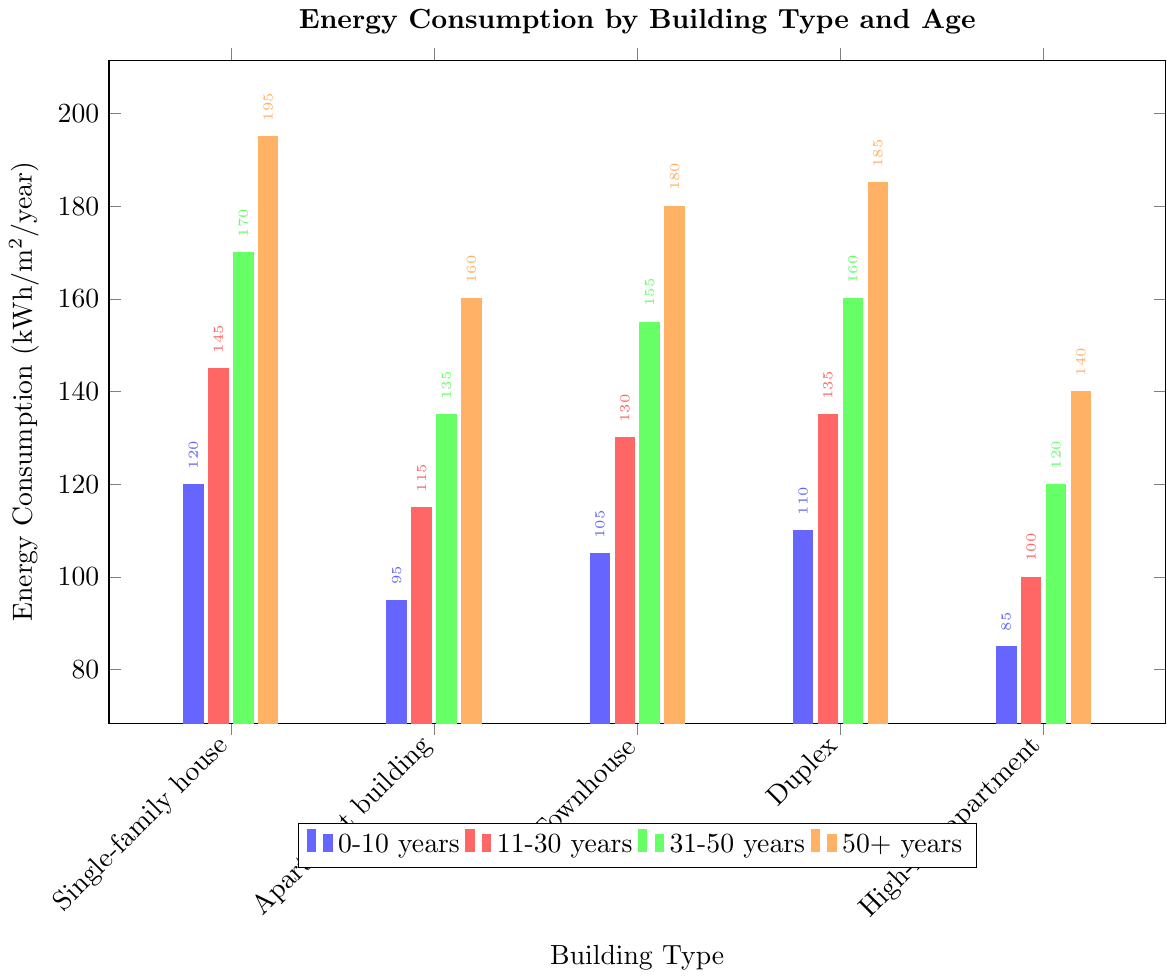How does energy consumption vary between the different building types for buildings that are 0-10 years old? To answer this question, compare the heights of the blue bars for each building type. Single-family house has 120 kWh/m²/year, Apartment building has 95 kWh/m²/year, Townhouse has 105 kWh/m²/year, Duplex has 110 kWh/m²/year, and High-rise apartment has 85 kWh/m²/year.
Answer: High-rise apartment consumes the least, followed by Apartment building, Townhouse, Duplex, and Single-family house consumes the most Which building type has the highest energy consumption for buildings aged 50+ years? For buildings aged 50+ years, look for the highest orange bar. Single-family house has 195 kWh/m²/year, Apartment building has 160 kWh/m²/year, Townhouse has 180 kWh/m²/year, Duplex has 185 kWh/m²/year, and High-rise apartment has 140 kWh/m²/year.
Answer: Single-family house How does the energy consumption of Duplexes change with building age? To answer this question, examine the heights of the bars for Duplexes across all age groups: 0-10 years is 110 kWh/m²/year, 11-30 years is 135 kWh/m²/year, 31-50 years is 160 kWh/m²/year, and 50+ years is 185 kWh/m²/year.
Answer: Increases with age Which age group shows the highest overall energy consumption? To determine this, look for the highest bar within each age group. The orange bars (50+ years) generally show the highest energy consumption across all building types.
Answer: 50+ years Is energy consumption more affected by building type or building age? Compare variations in bar height within each age group (across different building types) and within each building type (across different age groups). Significant increases in consumption with age are more evident than variations between building types of the same age group.
Answer: Building age What is the average energy consumption for Apartment buildings across all age groups? Sum the energy consumption values for Apartment buildings and divide by the number of age groups: (95 + 115 + 135 + 160) / 4.
Answer: 126.25 kWh/m²/year Compare the energy consumption of Single-family houses aged 0-10 years and High-rise apartments aged 50+ years. Look at the blue bar for Single-family houses and the orange bar for High-rise apartments. Single-family houses consume 120 kWh/m²/year, and High-rise apartments consume 140 kWh/m²/year.
Answer: High-rise apartments consume more For which building type does energy consumption increase the least with building age? Compare the differences in bar heights from 0-10 years to 50+ years for each building type. High-rise apartments go from 85 to 140, a difference of 55, which is the smallest increase compared to others.
Answer: High-rise apartment Which building type shows the most considerable increase in energy consumption from 0-10 years to 50+ years? Check the increments for each building type. Single-family house increases from 120 to 195, a difference of 75, which is the most significant increase.
Answer: Single-family house 